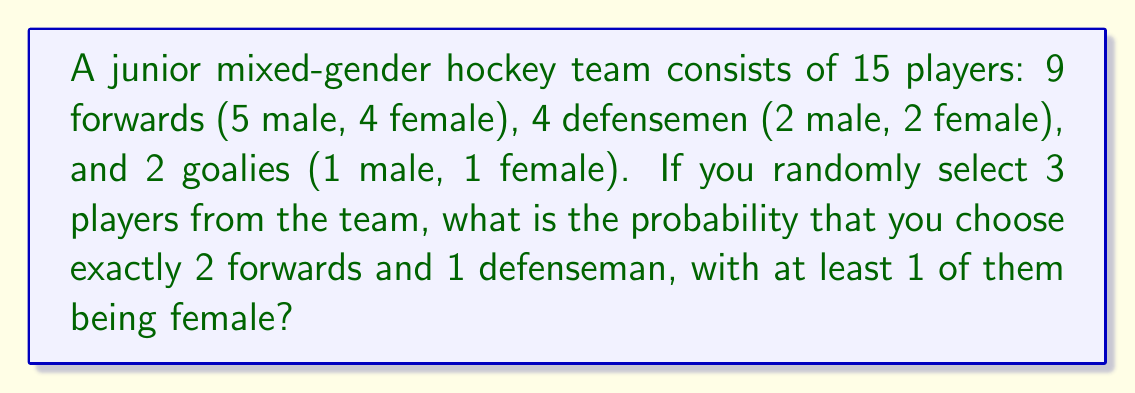Help me with this question. Let's approach this step-by-step:

1) First, we need to calculate the total number of ways to select 3 players from 15:
   $$\binom{15}{3} = \frac{15!}{3!(15-3)!} = 455$$

2) Now, we need to calculate the favorable outcomes. We can break this into two cases:
   a) 2 female forwards and 1 male defenseman
   b) At least 1 female forward and 1 female defenseman

3) For case a:
   $$\binom{4}{2} \times \binom{5}{0} \times \binom{2}{1} = 6 \times 1 \times 2 = 12$$

4) For case b:
   - 2 female forwards, 1 female defenseman: $\binom{4}{2} \times \binom{2}{1} = 6 \times 2 = 12$
   - 1 female forward, 1 male forward, 1 female defenseman: $\binom{4}{1} \times \binom{5}{1} \times \binom{2}{1} = 4 \times 5 \times 2 = 40$

5) Total favorable outcomes: $12 + 12 + 40 = 64$

6) Therefore, the probability is:
   $$P = \frac{64}{455} = \frac{64}{455} \approx 0.1407$$
Answer: $\frac{64}{455}$ 